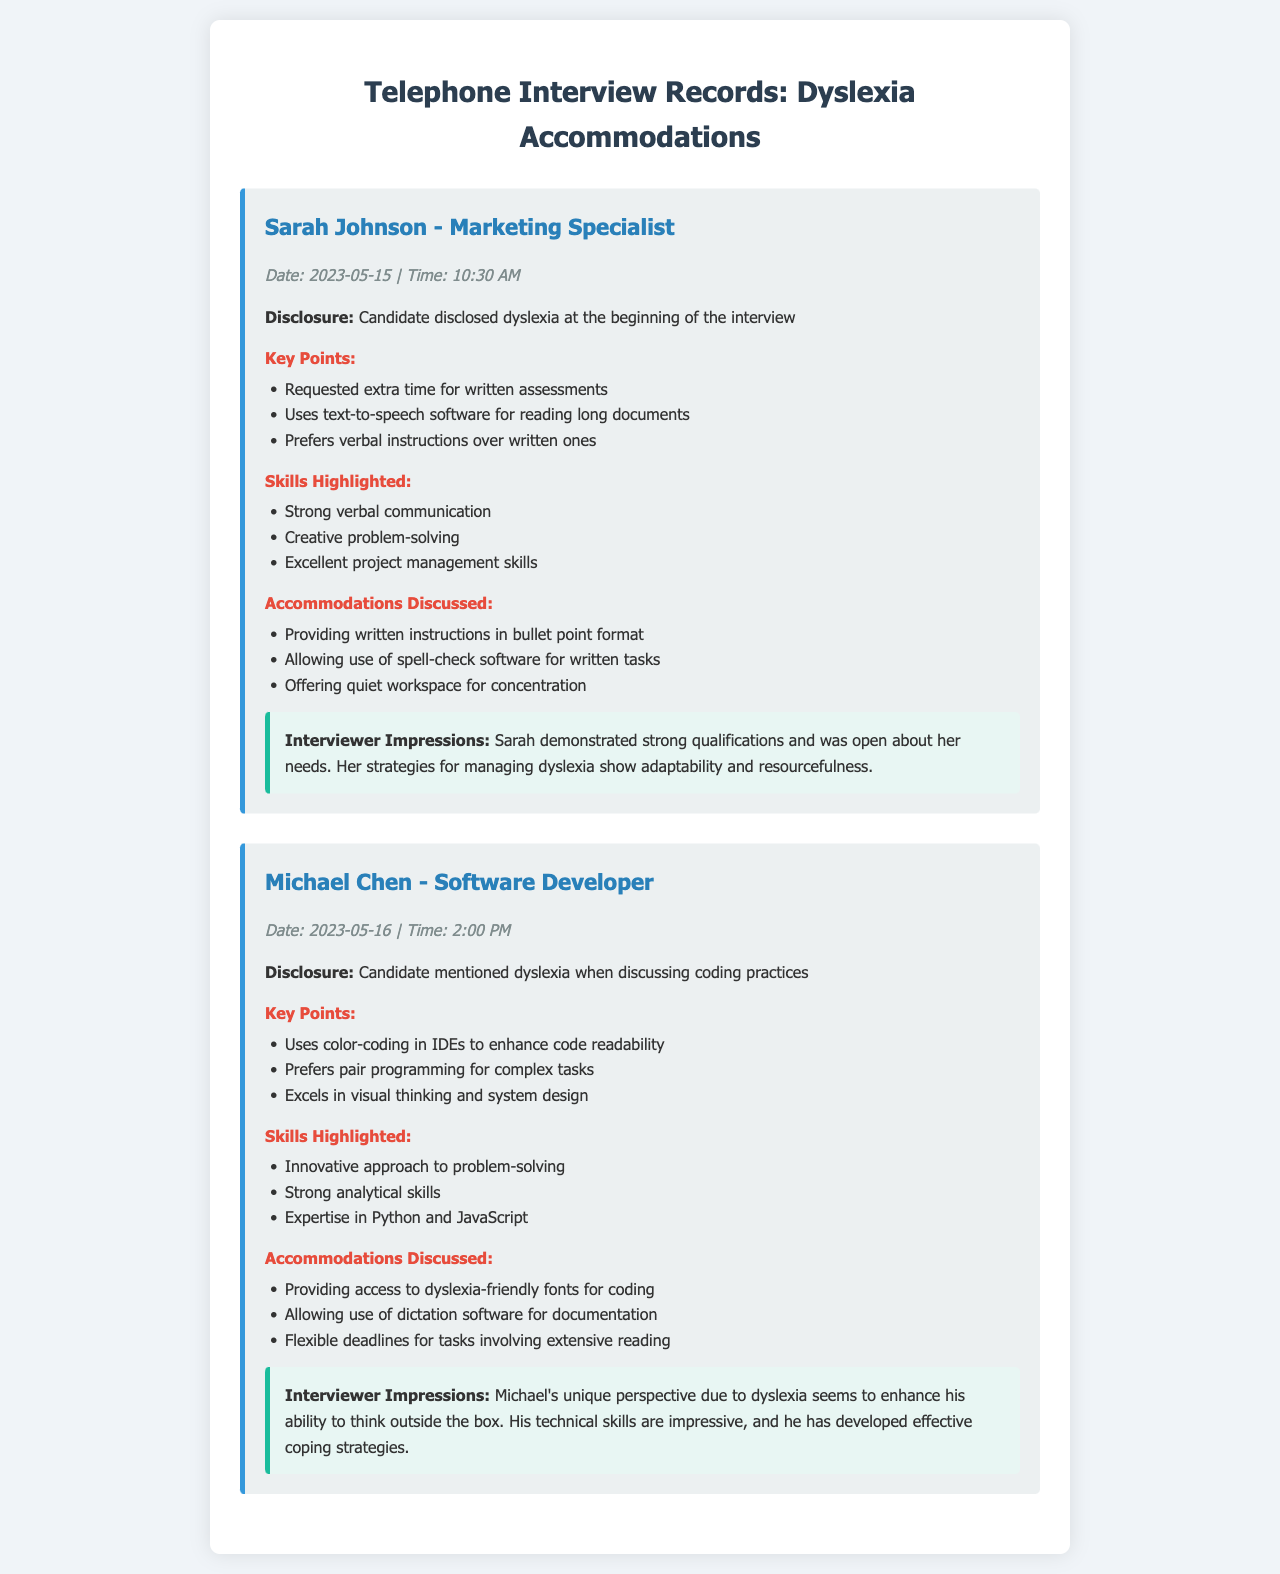What is the date of Sarah Johnson's interview? The date is specified in the document under the interview details for Sarah Johnson.
Answer: 2023-05-15 What software does Sarah Johnson use for reading long documents? The document states that Sarah uses text-to-speech software for reading long documents.
Answer: text-to-speech software What coding practices did Michael Chen mention in relation to his dyslexia? Michael mentioned dyslexia while discussing his coding practices, as noted in the disclosure section.
Answer: coding practices What skills were highlighted for Michael Chen? The skills highlighted for Michael Chen are documented, including innovative approaches and expertise in programming.
Answer: Innovative approach to problem-solving What specific accommodation did Sarah Johnson request for written assessments? Sarah Johnson requested specific accommodations during her interview, particularly for written assessments.
Answer: extra time for written assessments What time did Michael Chen's interview take place? The time of Michael Chen's interview is indicated in the interview details.
Answer: 2:00 PM Which task does Michael Chen prefer for complex programming work? The document mentions Michael Chen's preference for a specific task for complex programming, indicating collaboration.
Answer: pair programming What format did Sarah Johnson prefer for written instructions? The document states that Sarah Johnson prefers a certain format for written instructions, which aids her in managing her dyslexia.
Answer: bullet point format How did Michael Chen describe his thinking skills? The impressions about Michael Chen highlight his thinking skills, particularly in relation to his dyslexia.
Answer: visual thinking 